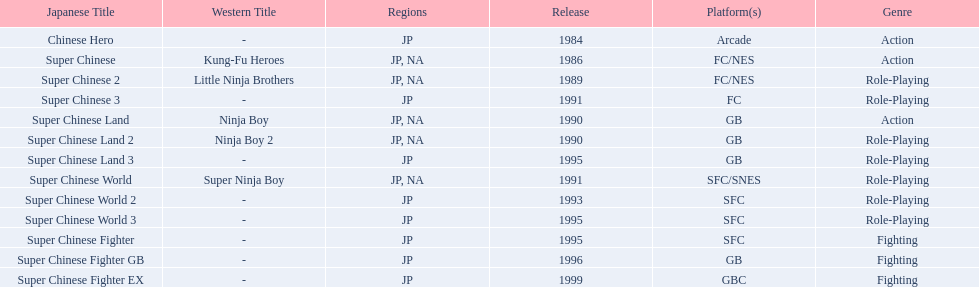In what territories was super ninja world made available? JP, NA. What was the primary name for this title? Super Chinese World. 